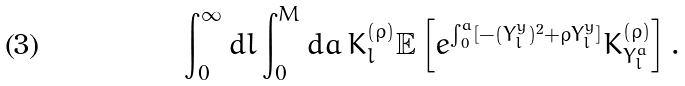Convert formula to latex. <formula><loc_0><loc_0><loc_500><loc_500>\int _ { 0 } ^ { \infty } d l \int _ { 0 } ^ { M } d a \, \bar { K } ^ { ( \rho ) } _ { l } \mathbb { E } \left [ e ^ { \int _ { 0 } ^ { a } [ - ( Y _ { l } ^ { y } ) ^ { 2 } + \rho Y _ { l } ^ { y } ] } \bar { K } ^ { ( \rho ) } _ { Y _ { l } ^ { a } } \right ] .</formula> 